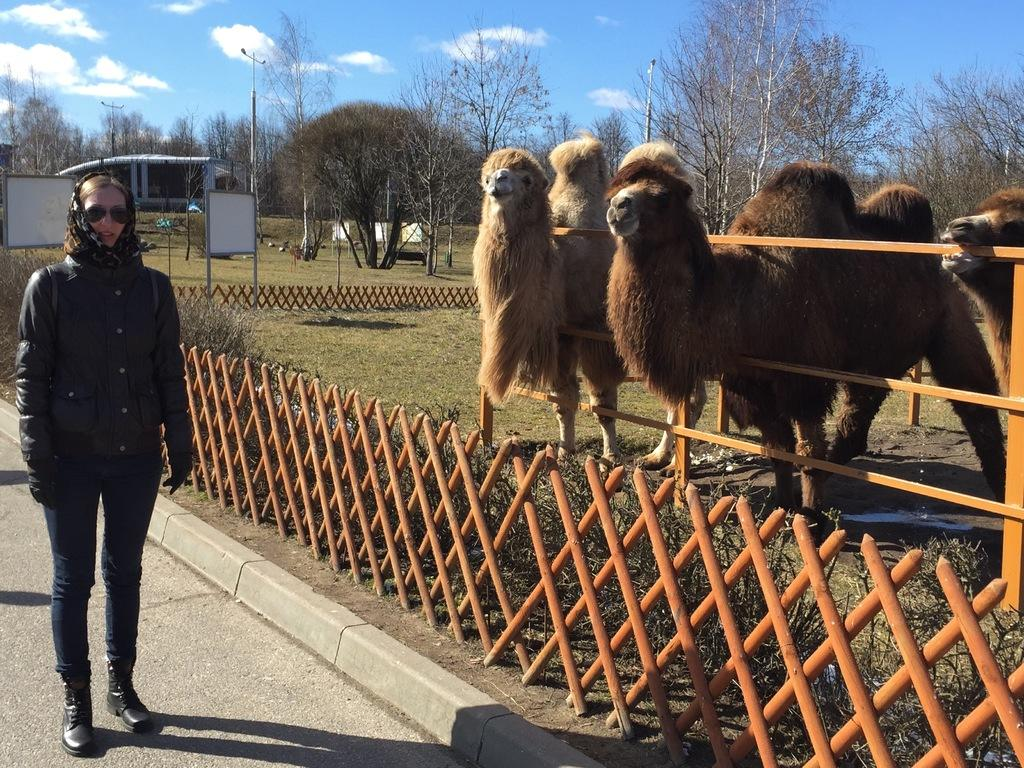What type of surface is visible in the image? There is ground visible in the image. What is the person in the image doing? A person is standing on the ground. What can be seen near the person in the image? There is railing in the image. What type of living organisms are present in the image? There are animals in the image. What type of vegetation is present in the image? There are trees in the image. What type of structures are present in the image? There are poles and boards in the image. What is visible in the background of the image? The sky is visible in the background of the image. What type of feather can be seen on the person's hat in the image? There is no feather visible on the person's hat in the image. What type of umbrella is being used by the animals in the image? There are no umbrellas present in the image, and the animals are not using any umbrellas. 